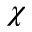<formula> <loc_0><loc_0><loc_500><loc_500>\chi</formula> 